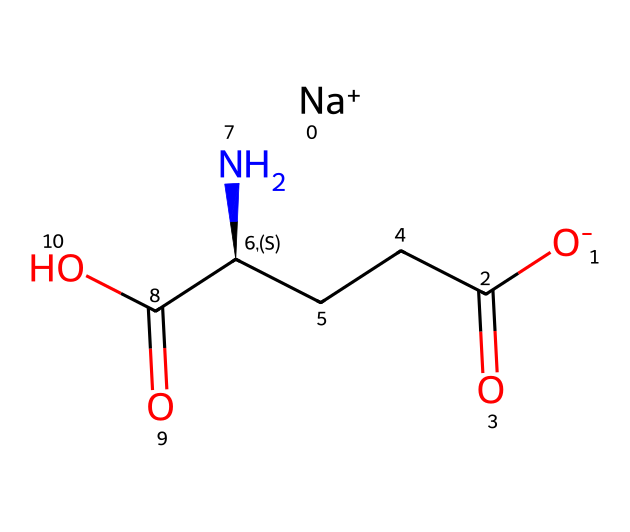What is the molecular formula of monosodium glutamate? The SMILES notation indicates the presence of carbon (C), hydrogen (H), oxygen (O), and sodium (Na) atoms. Counting the atoms from the formula, the molecular formula can be derived as C5H8NNaO4.
Answer: C5H8NNaO4 How many carbon atoms are present in monosodium glutamate? Looking at the SMILES representation, the 'C' occurrences can be counted. There are five carbon atoms present in the structure.
Answer: 5 Does monosodium glutamate contain nitrogen atoms? The presence of the letter 'N' in the SMILES notation indicates that there is one nitrogen atom in the structure.
Answer: Yes What is the charge of the sodium ion in monosodium glutamate? In the SMILES, the notation '[Na+]' signifies that the sodium ion has a positive charge, which is indicated by the '+' sign.
Answer: +1 How many functional groups are present in monosodium glutamate? Analyzing the structure from the SMILES, it contains a carboxyl group (-COOH) and an amino group (-NH2). Counting these, there are two distinct functional groups.
Answer: 2 What is the role of monosodium glutamate in food? Monosodium glutamate acts as a flavor enhancer, which can be attributed to its ability to enhance umami taste in foods.
Answer: Flavor enhancer Is monosodium glutamate soluble in water? Due to the ionic nature of the sodium ion and the polar nature of the glutamate part of the molecule, monosodium glutamate is generally considered soluble in water.
Answer: Yes 